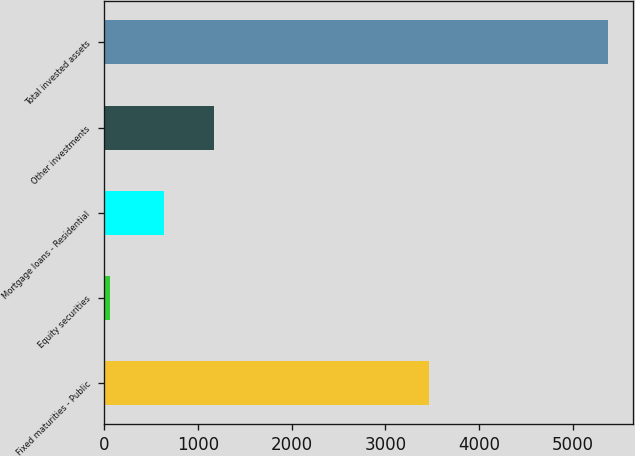Convert chart to OTSL. <chart><loc_0><loc_0><loc_500><loc_500><bar_chart><fcel>Fixed maturities - Public<fcel>Equity securities<fcel>Mortgage loans - Residential<fcel>Other investments<fcel>Total invested assets<nl><fcel>3470.2<fcel>62.7<fcel>638.6<fcel>1169.49<fcel>5371.6<nl></chart> 